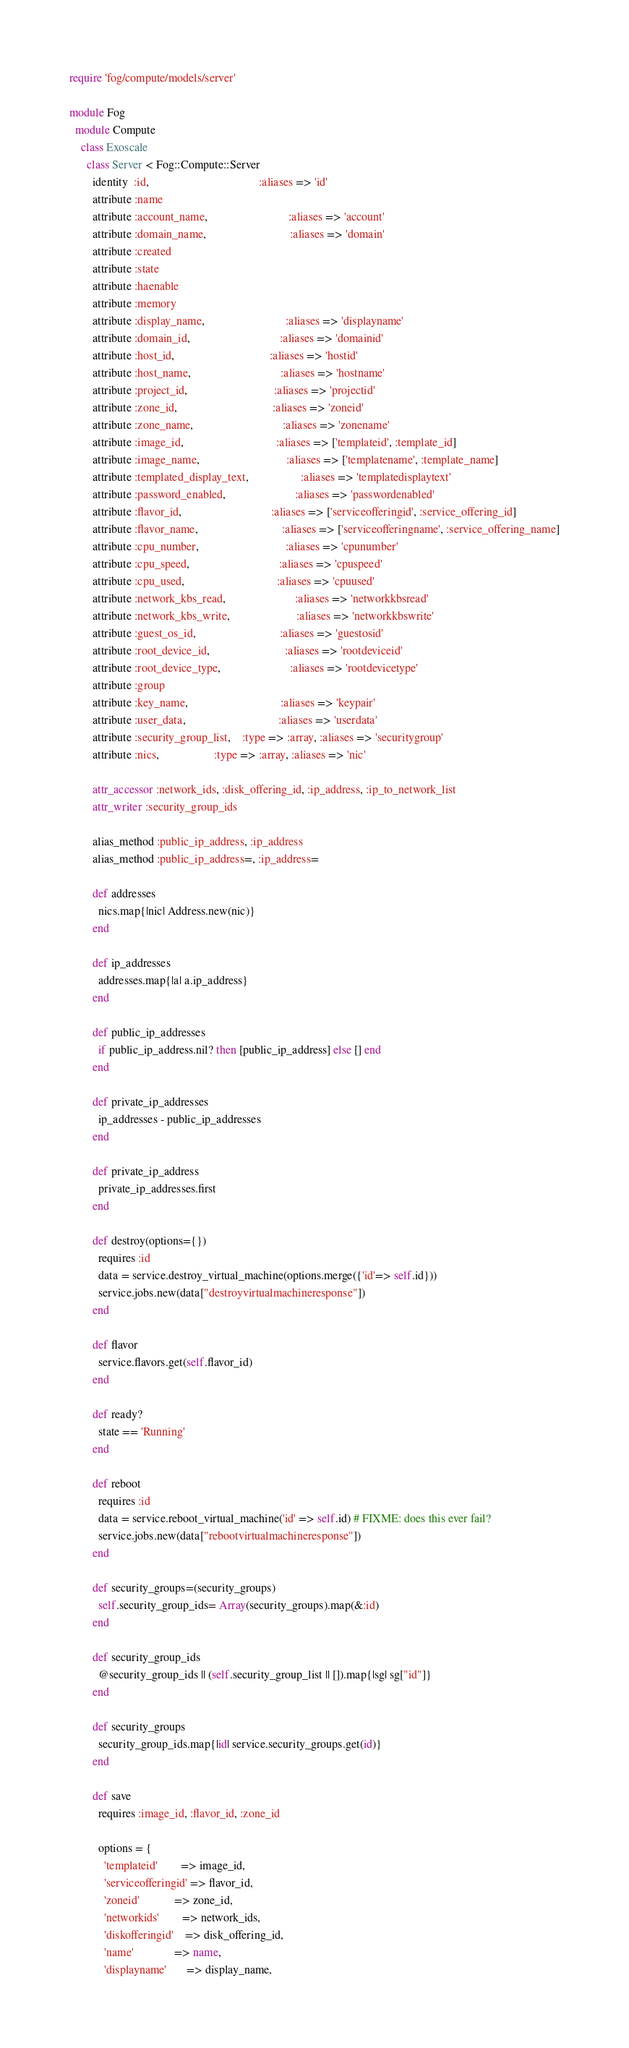<code> <loc_0><loc_0><loc_500><loc_500><_Ruby_>require 'fog/compute/models/server'

module Fog
  module Compute
    class Exoscale
      class Server < Fog::Compute::Server
        identity  :id,                                      :aliases => 'id'
        attribute :name
        attribute :account_name,                            :aliases => 'account'
        attribute :domain_name,                             :aliases => 'domain'
        attribute :created
        attribute :state
        attribute :haenable
        attribute :memory
        attribute :display_name,                            :aliases => 'displayname'
        attribute :domain_id,                               :aliases => 'domainid'
        attribute :host_id,                                 :aliases => 'hostid'
        attribute :host_name,                               :aliases => 'hostname'
        attribute :project_id,                              :aliases => 'projectid'
        attribute :zone_id,                                 :aliases => 'zoneid'
        attribute :zone_name,                               :aliases => 'zonename'
        attribute :image_id,                                :aliases => ['templateid', :template_id]
        attribute :image_name,                              :aliases => ['templatename', :template_name]
        attribute :templated_display_text,                  :aliases => 'templatedisplaytext'
        attribute :password_enabled,                        :aliases => 'passwordenabled'
        attribute :flavor_id,                               :aliases => ['serviceofferingid', :service_offering_id]
        attribute :flavor_name,                             :aliases => ['serviceofferingname', :service_offering_name]
        attribute :cpu_number,                              :aliases => 'cpunumber'
        attribute :cpu_speed,                               :aliases => 'cpuspeed'
        attribute :cpu_used,                                :aliases => 'cpuused'
        attribute :network_kbs_read,                        :aliases => 'networkkbsread'
        attribute :network_kbs_write,                       :aliases => 'networkkbswrite'
        attribute :guest_os_id,                             :aliases => 'guestosid'
        attribute :root_device_id,                          :aliases => 'rootdeviceid'
        attribute :root_device_type,                        :aliases => 'rootdevicetype'
        attribute :group
        attribute :key_name,                                :aliases => 'keypair'
        attribute :user_data,                                :aliases => 'userdata'
        attribute :security_group_list,    :type => :array, :aliases => 'securitygroup'
        attribute :nics,                   :type => :array, :aliases => 'nic'

        attr_accessor :network_ids, :disk_offering_id, :ip_address, :ip_to_network_list
        attr_writer :security_group_ids

        alias_method :public_ip_address, :ip_address
        alias_method :public_ip_address=, :ip_address=

        def addresses
          nics.map{|nic| Address.new(nic)}
        end

        def ip_addresses
          addresses.map{|a| a.ip_address}
        end

        def public_ip_addresses
          if public_ip_address.nil? then [public_ip_address] else [] end
        end

        def private_ip_addresses
          ip_addresses - public_ip_addresses
        end

        def private_ip_address
          private_ip_addresses.first
        end

        def destroy(options={})
          requires :id
          data = service.destroy_virtual_machine(options.merge({'id'=> self.id}))
          service.jobs.new(data["destroyvirtualmachineresponse"])
        end

        def flavor
          service.flavors.get(self.flavor_id)
        end

        def ready?
          state == 'Running'
        end

        def reboot
          requires :id
          data = service.reboot_virtual_machine('id' => self.id) # FIXME: does this ever fail?
          service.jobs.new(data["rebootvirtualmachineresponse"])
        end

        def security_groups=(security_groups)
          self.security_group_ids= Array(security_groups).map(&:id)
        end

        def security_group_ids
          @security_group_ids || (self.security_group_list || []).map{|sg| sg["id"]}
        end

        def security_groups
          security_group_ids.map{|id| service.security_groups.get(id)}
        end

        def save
          requires :image_id, :flavor_id, :zone_id

          options = {
            'templateid'        => image_id,
            'serviceofferingid' => flavor_id,
            'zoneid'            => zone_id,
            'networkids'        => network_ids,
            'diskofferingid'    => disk_offering_id,
            'name'              => name,
            'displayname'       => display_name,</code> 